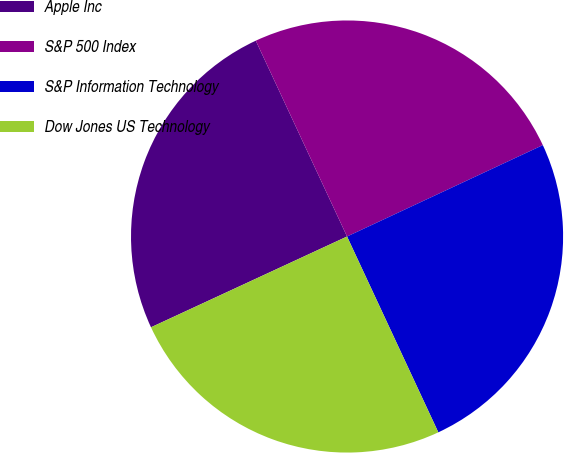Convert chart to OTSL. <chart><loc_0><loc_0><loc_500><loc_500><pie_chart><fcel>Apple Inc<fcel>S&P 500 Index<fcel>S&P Information Technology<fcel>Dow Jones US Technology<nl><fcel>24.96%<fcel>24.99%<fcel>25.01%<fcel>25.04%<nl></chart> 